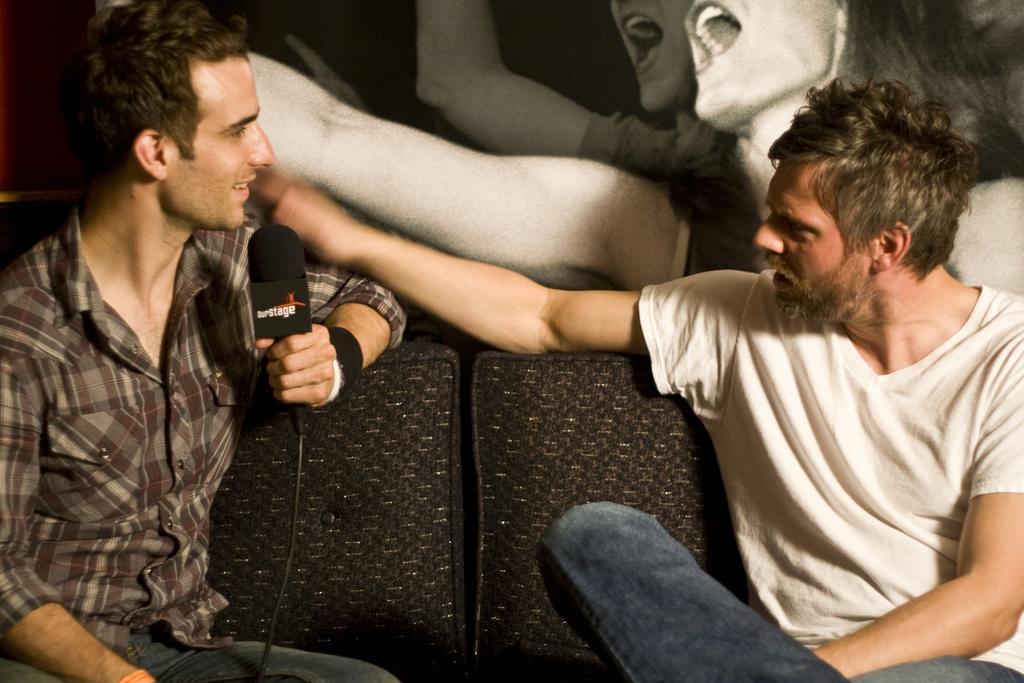Can you describe this image briefly? in this image the two persons they are sitting on the chair and they could be talking each other they two persons they are wearing the jeans and shirt the left person is sitting on the left he is holding the mike and the background is white. 